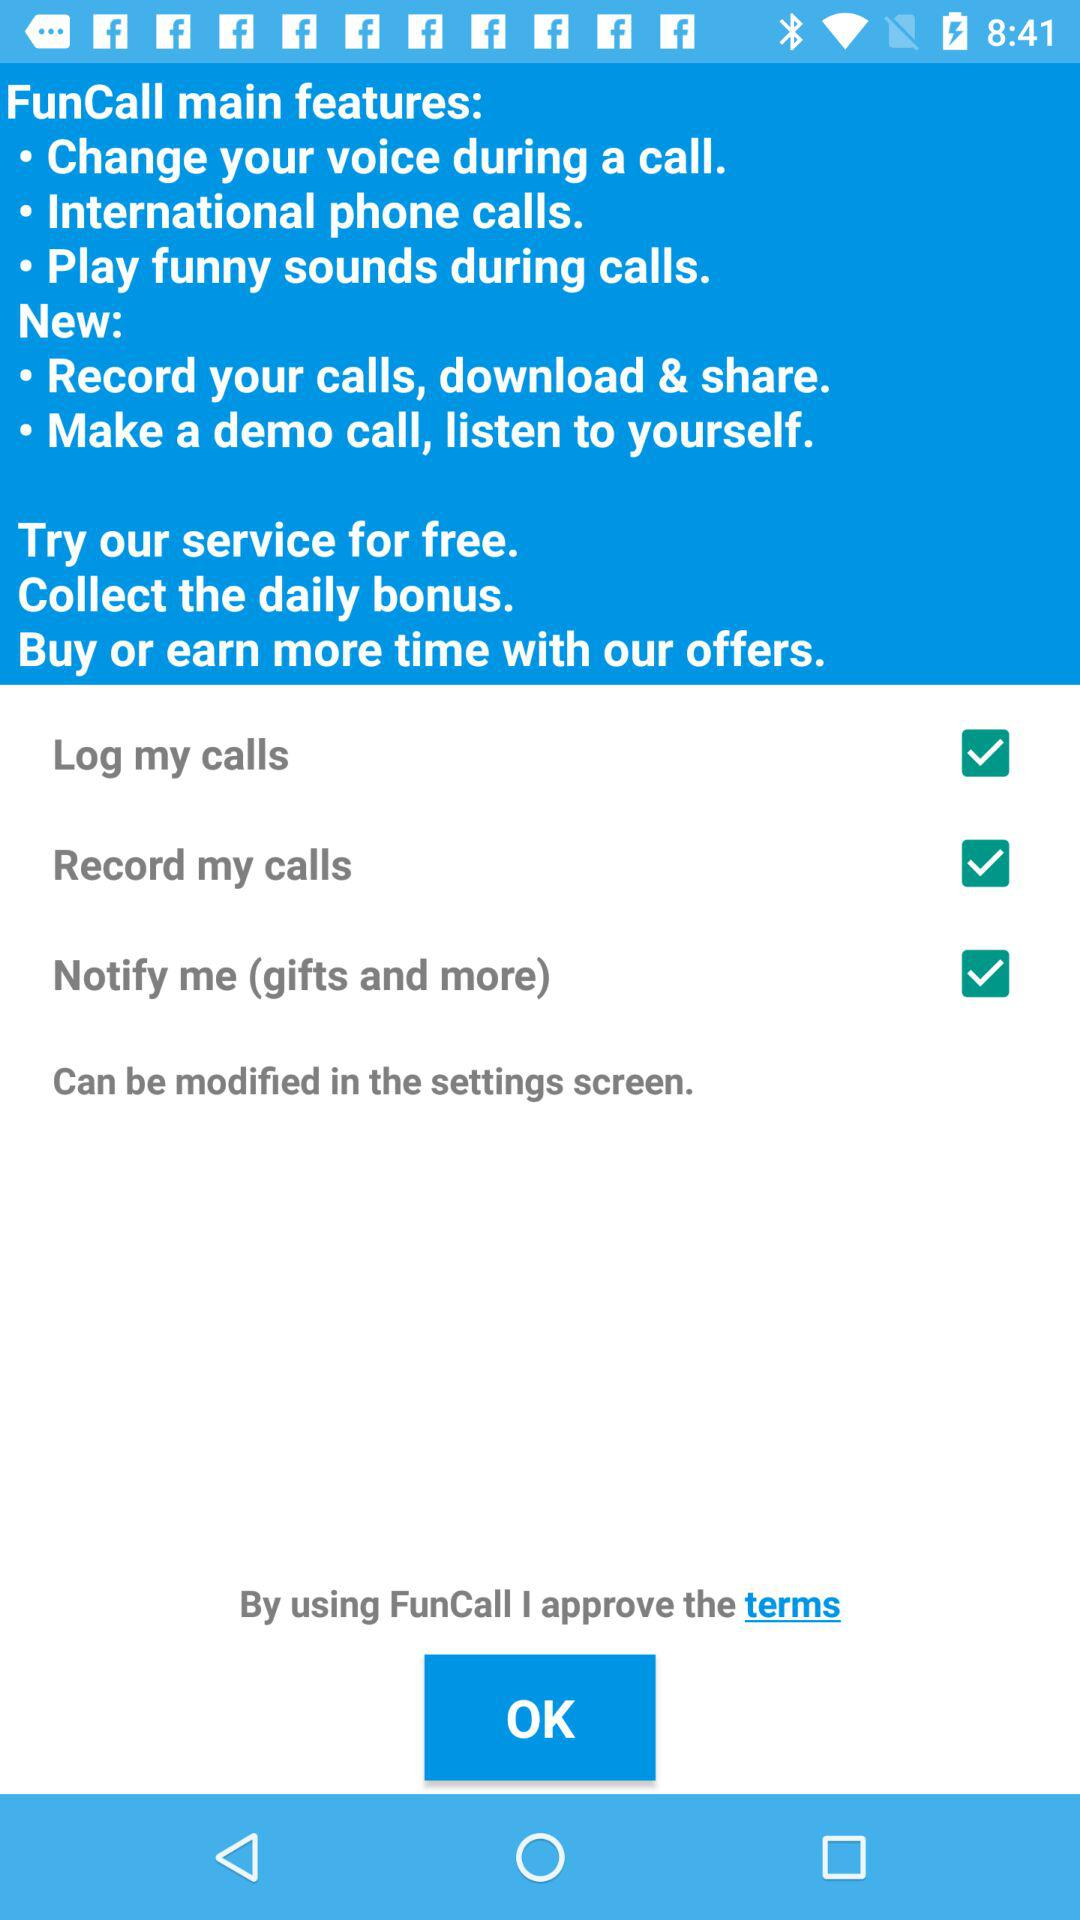Where can the settings be modified? The settings can be modified in the settings screen. 